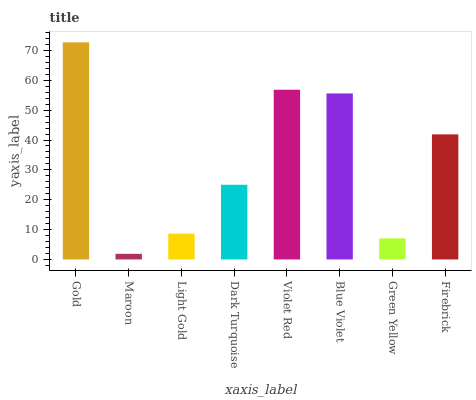Is Light Gold the minimum?
Answer yes or no. No. Is Light Gold the maximum?
Answer yes or no. No. Is Light Gold greater than Maroon?
Answer yes or no. Yes. Is Maroon less than Light Gold?
Answer yes or no. Yes. Is Maroon greater than Light Gold?
Answer yes or no. No. Is Light Gold less than Maroon?
Answer yes or no. No. Is Firebrick the high median?
Answer yes or no. Yes. Is Dark Turquoise the low median?
Answer yes or no. Yes. Is Maroon the high median?
Answer yes or no. No. Is Light Gold the low median?
Answer yes or no. No. 